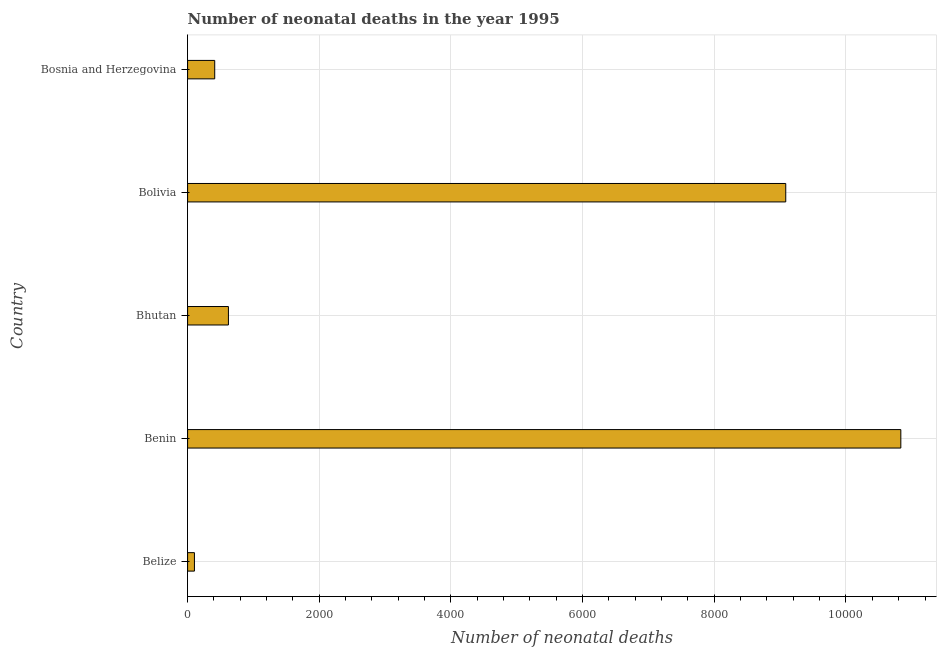Does the graph contain any zero values?
Provide a short and direct response. No. Does the graph contain grids?
Make the answer very short. Yes. What is the title of the graph?
Offer a terse response. Number of neonatal deaths in the year 1995. What is the label or title of the X-axis?
Make the answer very short. Number of neonatal deaths. What is the number of neonatal deaths in Bhutan?
Your response must be concise. 620. Across all countries, what is the maximum number of neonatal deaths?
Your response must be concise. 1.08e+04. Across all countries, what is the minimum number of neonatal deaths?
Your answer should be compact. 104. In which country was the number of neonatal deaths maximum?
Your answer should be very brief. Benin. In which country was the number of neonatal deaths minimum?
Offer a terse response. Belize. What is the sum of the number of neonatal deaths?
Your response must be concise. 2.11e+04. What is the difference between the number of neonatal deaths in Belize and Bhutan?
Provide a short and direct response. -516. What is the average number of neonatal deaths per country?
Provide a succinct answer. 4210. What is the median number of neonatal deaths?
Offer a very short reply. 620. What is the ratio of the number of neonatal deaths in Benin to that in Bolivia?
Provide a succinct answer. 1.19. Is the number of neonatal deaths in Benin less than that in Bolivia?
Offer a terse response. No. What is the difference between the highest and the second highest number of neonatal deaths?
Provide a succinct answer. 1748. Is the sum of the number of neonatal deaths in Benin and Bosnia and Herzegovina greater than the maximum number of neonatal deaths across all countries?
Offer a terse response. Yes. What is the difference between the highest and the lowest number of neonatal deaths?
Your answer should be very brief. 1.07e+04. In how many countries, is the number of neonatal deaths greater than the average number of neonatal deaths taken over all countries?
Your response must be concise. 2. How many bars are there?
Ensure brevity in your answer.  5. Are all the bars in the graph horizontal?
Offer a very short reply. Yes. What is the difference between two consecutive major ticks on the X-axis?
Your answer should be very brief. 2000. What is the Number of neonatal deaths of Belize?
Give a very brief answer. 104. What is the Number of neonatal deaths in Benin?
Your answer should be very brief. 1.08e+04. What is the Number of neonatal deaths in Bhutan?
Provide a succinct answer. 620. What is the Number of neonatal deaths of Bolivia?
Provide a short and direct response. 9085. What is the Number of neonatal deaths of Bosnia and Herzegovina?
Offer a terse response. 412. What is the difference between the Number of neonatal deaths in Belize and Benin?
Offer a terse response. -1.07e+04. What is the difference between the Number of neonatal deaths in Belize and Bhutan?
Provide a succinct answer. -516. What is the difference between the Number of neonatal deaths in Belize and Bolivia?
Make the answer very short. -8981. What is the difference between the Number of neonatal deaths in Belize and Bosnia and Herzegovina?
Give a very brief answer. -308. What is the difference between the Number of neonatal deaths in Benin and Bhutan?
Give a very brief answer. 1.02e+04. What is the difference between the Number of neonatal deaths in Benin and Bolivia?
Your answer should be very brief. 1748. What is the difference between the Number of neonatal deaths in Benin and Bosnia and Herzegovina?
Keep it short and to the point. 1.04e+04. What is the difference between the Number of neonatal deaths in Bhutan and Bolivia?
Make the answer very short. -8465. What is the difference between the Number of neonatal deaths in Bhutan and Bosnia and Herzegovina?
Provide a succinct answer. 208. What is the difference between the Number of neonatal deaths in Bolivia and Bosnia and Herzegovina?
Your answer should be compact. 8673. What is the ratio of the Number of neonatal deaths in Belize to that in Benin?
Your answer should be very brief. 0.01. What is the ratio of the Number of neonatal deaths in Belize to that in Bhutan?
Provide a short and direct response. 0.17. What is the ratio of the Number of neonatal deaths in Belize to that in Bolivia?
Offer a terse response. 0.01. What is the ratio of the Number of neonatal deaths in Belize to that in Bosnia and Herzegovina?
Your response must be concise. 0.25. What is the ratio of the Number of neonatal deaths in Benin to that in Bhutan?
Your answer should be very brief. 17.47. What is the ratio of the Number of neonatal deaths in Benin to that in Bolivia?
Offer a terse response. 1.19. What is the ratio of the Number of neonatal deaths in Benin to that in Bosnia and Herzegovina?
Ensure brevity in your answer.  26.29. What is the ratio of the Number of neonatal deaths in Bhutan to that in Bolivia?
Ensure brevity in your answer.  0.07. What is the ratio of the Number of neonatal deaths in Bhutan to that in Bosnia and Herzegovina?
Keep it short and to the point. 1.5. What is the ratio of the Number of neonatal deaths in Bolivia to that in Bosnia and Herzegovina?
Your answer should be compact. 22.05. 